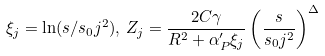Convert formula to latex. <formula><loc_0><loc_0><loc_500><loc_500>\xi _ { j } = \ln ( s / s _ { 0 } j ^ { 2 } ) , \, Z _ { j } = \frac { 2 C \gamma } { R ^ { 2 } + \alpha _ { P } ^ { \prime } \xi _ { j } } \left ( \frac { s } { s _ { 0 } j ^ { 2 } } \right ) ^ { \Delta }</formula> 